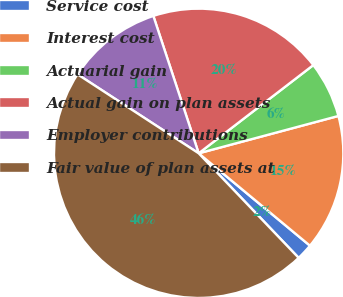Convert chart to OTSL. <chart><loc_0><loc_0><loc_500><loc_500><pie_chart><fcel>Service cost<fcel>Interest cost<fcel>Actuarial gain<fcel>Actual gain on plan assets<fcel>Employer contributions<fcel>Fair value of plan assets at<nl><fcel>1.83%<fcel>15.18%<fcel>6.28%<fcel>19.63%<fcel>10.73%<fcel>46.33%<nl></chart> 